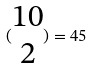<formula> <loc_0><loc_0><loc_500><loc_500>( \begin{matrix} 1 0 \\ 2 \end{matrix} ) = 4 5</formula> 